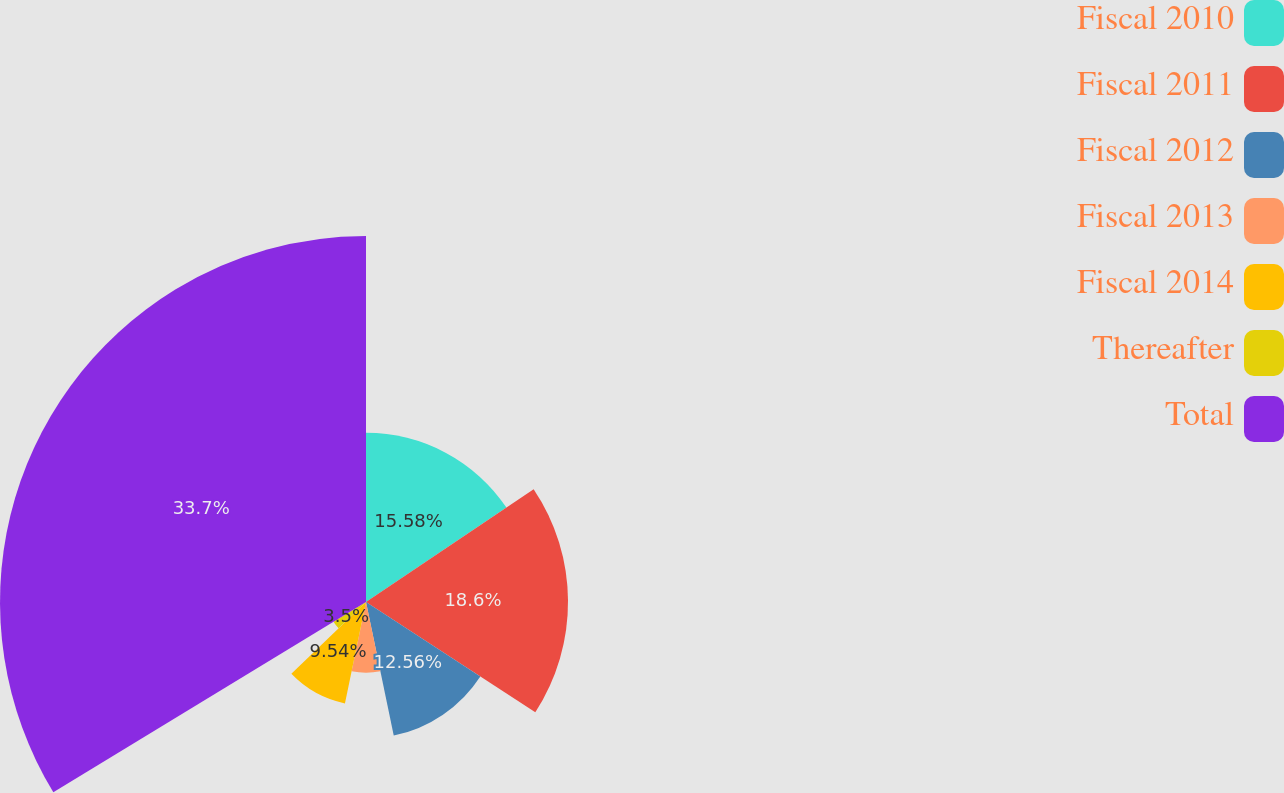<chart> <loc_0><loc_0><loc_500><loc_500><pie_chart><fcel>Fiscal 2010<fcel>Fiscal 2011<fcel>Fiscal 2012<fcel>Fiscal 2013<fcel>Fiscal 2014<fcel>Thereafter<fcel>Total<nl><fcel>15.58%<fcel>18.6%<fcel>12.56%<fcel>6.52%<fcel>9.54%<fcel>3.5%<fcel>33.7%<nl></chart> 